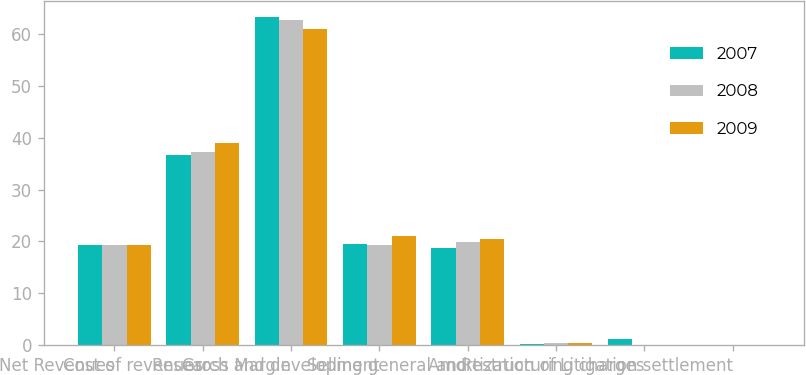Convert chart. <chart><loc_0><loc_0><loc_500><loc_500><stacked_bar_chart><ecel><fcel>Net Revenues<fcel>Cost of revenues<fcel>Gross Margin<fcel>Research and development<fcel>Selling general and<fcel>Amortization of<fcel>Restructuring charges<fcel>Litigation settlement<nl><fcel>2007<fcel>19.4<fcel>36.7<fcel>63.3<fcel>19.5<fcel>18.8<fcel>0.3<fcel>1.2<fcel>0<nl><fcel>2008<fcel>19.4<fcel>37.3<fcel>62.7<fcel>19.4<fcel>19.9<fcel>0.4<fcel>0<fcel>0<nl><fcel>2009<fcel>19.4<fcel>39<fcel>61<fcel>21.1<fcel>20.4<fcel>0.4<fcel>0<fcel>0.1<nl></chart> 